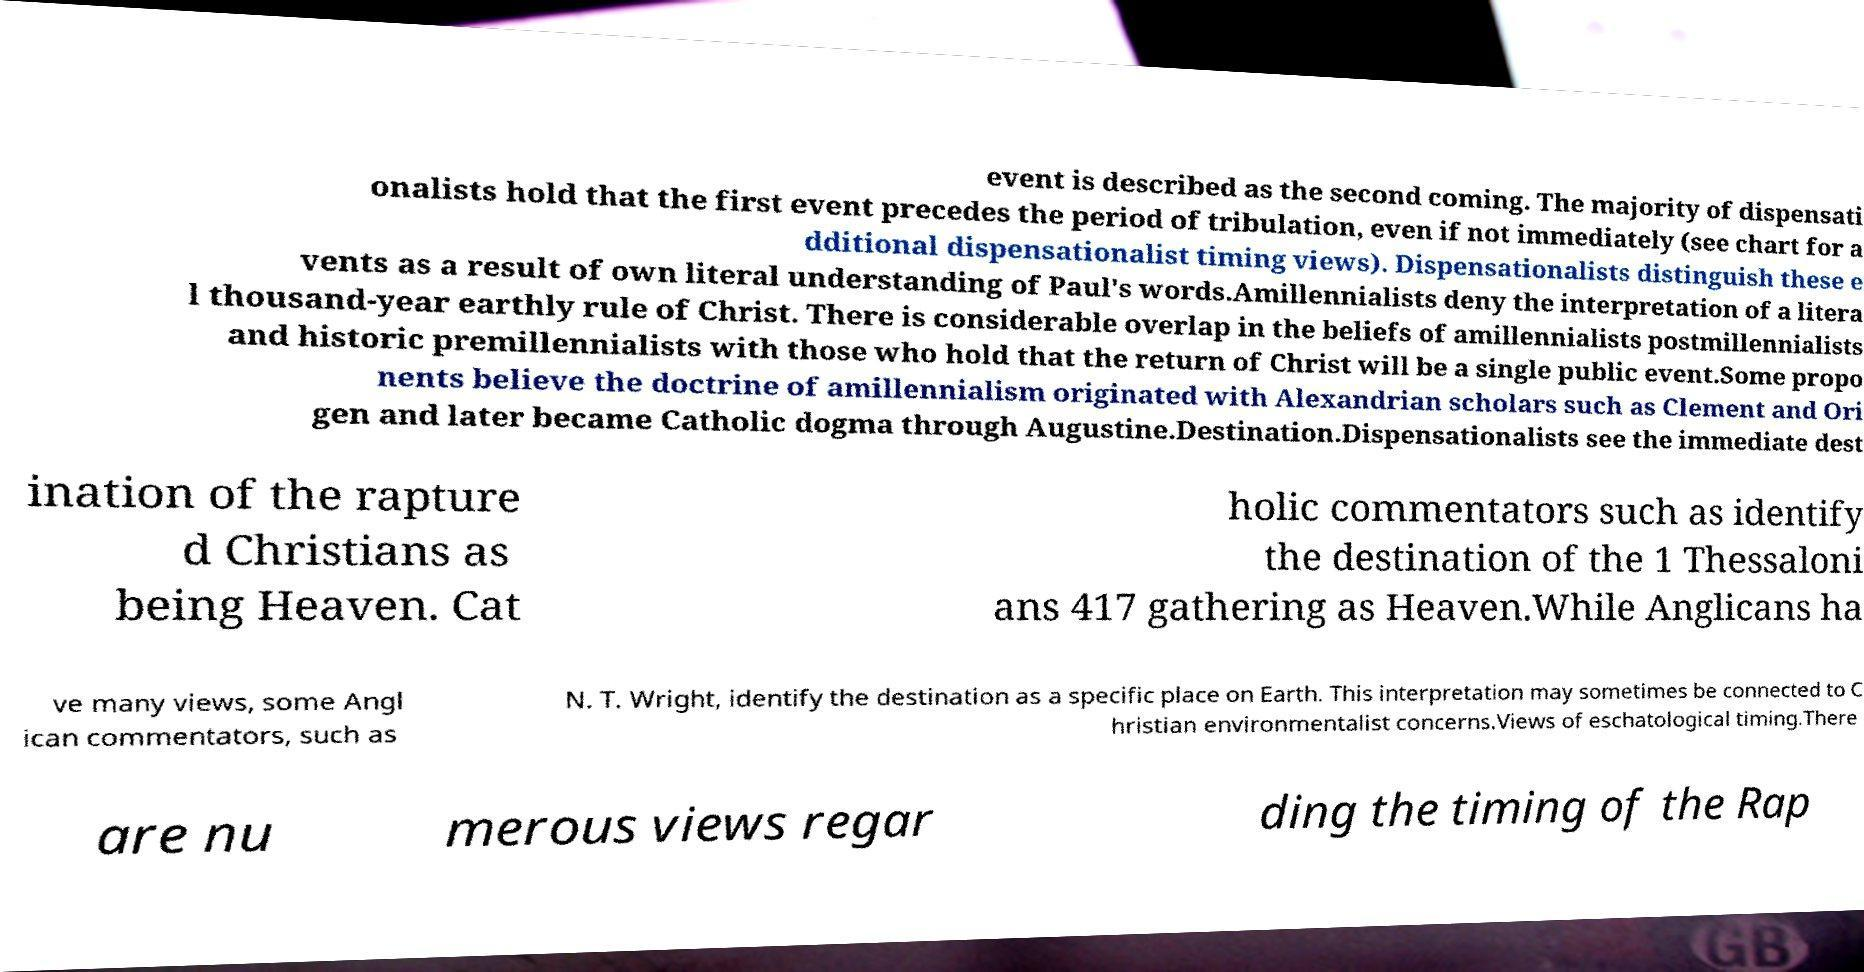I need the written content from this picture converted into text. Can you do that? event is described as the second coming. The majority of dispensati onalists hold that the first event precedes the period of tribulation, even if not immediately (see chart for a dditional dispensationalist timing views). Dispensationalists distinguish these e vents as a result of own literal understanding of Paul's words.Amillennialists deny the interpretation of a litera l thousand-year earthly rule of Christ. There is considerable overlap in the beliefs of amillennialists postmillennialists and historic premillennialists with those who hold that the return of Christ will be a single public event.Some propo nents believe the doctrine of amillennialism originated with Alexandrian scholars such as Clement and Ori gen and later became Catholic dogma through Augustine.Destination.Dispensationalists see the immediate dest ination of the rapture d Christians as being Heaven. Cat holic commentators such as identify the destination of the 1 Thessaloni ans 417 gathering as Heaven.While Anglicans ha ve many views, some Angl ican commentators, such as N. T. Wright, identify the destination as a specific place on Earth. This interpretation may sometimes be connected to C hristian environmentalist concerns.Views of eschatological timing.There are nu merous views regar ding the timing of the Rap 